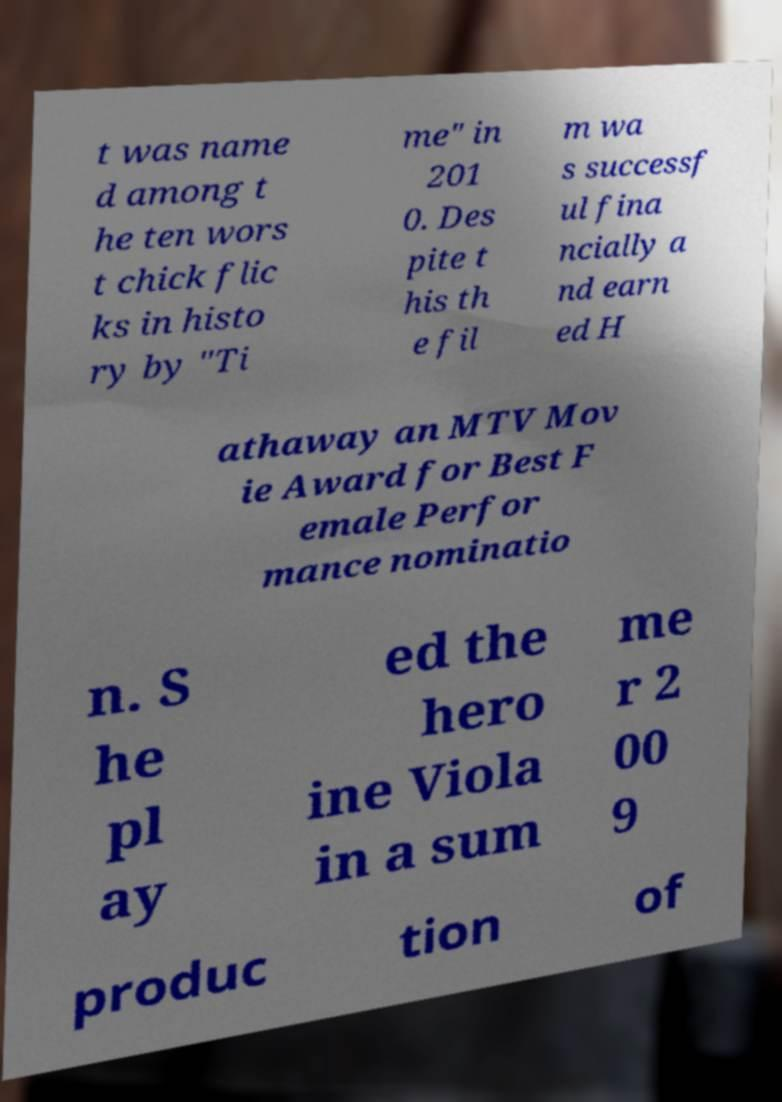Please identify and transcribe the text found in this image. t was name d among t he ten wors t chick flic ks in histo ry by "Ti me" in 201 0. Des pite t his th e fil m wa s successf ul fina ncially a nd earn ed H athaway an MTV Mov ie Award for Best F emale Perfor mance nominatio n. S he pl ay ed the hero ine Viola in a sum me r 2 00 9 produc tion of 